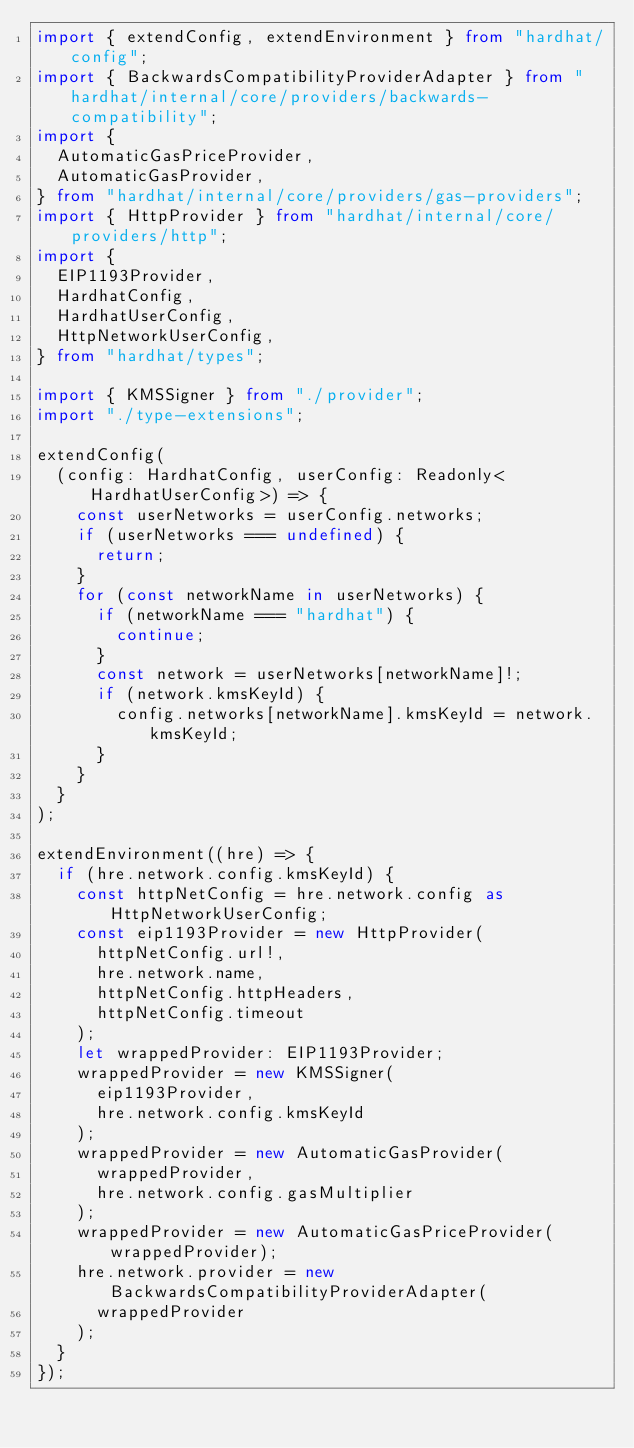<code> <loc_0><loc_0><loc_500><loc_500><_TypeScript_>import { extendConfig, extendEnvironment } from "hardhat/config";
import { BackwardsCompatibilityProviderAdapter } from "hardhat/internal/core/providers/backwards-compatibility";
import {
  AutomaticGasPriceProvider,
  AutomaticGasProvider,
} from "hardhat/internal/core/providers/gas-providers";
import { HttpProvider } from "hardhat/internal/core/providers/http";
import {
  EIP1193Provider,
  HardhatConfig,
  HardhatUserConfig,
  HttpNetworkUserConfig,
} from "hardhat/types";

import { KMSSigner } from "./provider";
import "./type-extensions";

extendConfig(
  (config: HardhatConfig, userConfig: Readonly<HardhatUserConfig>) => {
    const userNetworks = userConfig.networks;
    if (userNetworks === undefined) {
      return;
    }
    for (const networkName in userNetworks) {
      if (networkName === "hardhat") {
        continue;
      }
      const network = userNetworks[networkName]!;
      if (network.kmsKeyId) {
        config.networks[networkName].kmsKeyId = network.kmsKeyId;
      }
    }
  }
);

extendEnvironment((hre) => {
  if (hre.network.config.kmsKeyId) {
    const httpNetConfig = hre.network.config as HttpNetworkUserConfig;
    const eip1193Provider = new HttpProvider(
      httpNetConfig.url!,
      hre.network.name,
      httpNetConfig.httpHeaders,
      httpNetConfig.timeout
    );
    let wrappedProvider: EIP1193Provider;
    wrappedProvider = new KMSSigner(
      eip1193Provider,
      hre.network.config.kmsKeyId
    );
    wrappedProvider = new AutomaticGasProvider(
      wrappedProvider,
      hre.network.config.gasMultiplier
    );
    wrappedProvider = new AutomaticGasPriceProvider(wrappedProvider);
    hre.network.provider = new BackwardsCompatibilityProviderAdapter(
      wrappedProvider
    );
  }
});
</code> 